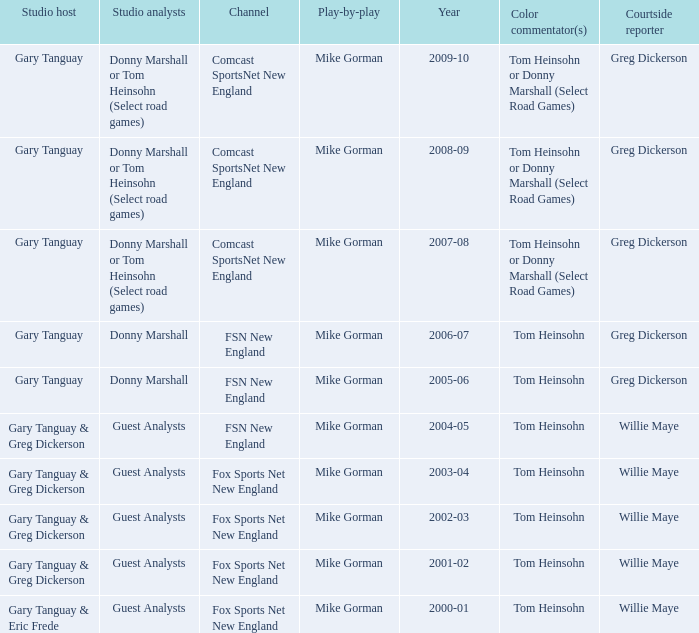WHich Studio host has a Year of 2003-04? Gary Tanguay & Greg Dickerson. 